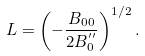Convert formula to latex. <formula><loc_0><loc_0><loc_500><loc_500>L = \left ( - \frac { B _ { 0 0 } } { 2 B _ { 0 } ^ { ^ { \prime \prime } } } \right ) ^ { 1 / 2 } .</formula> 